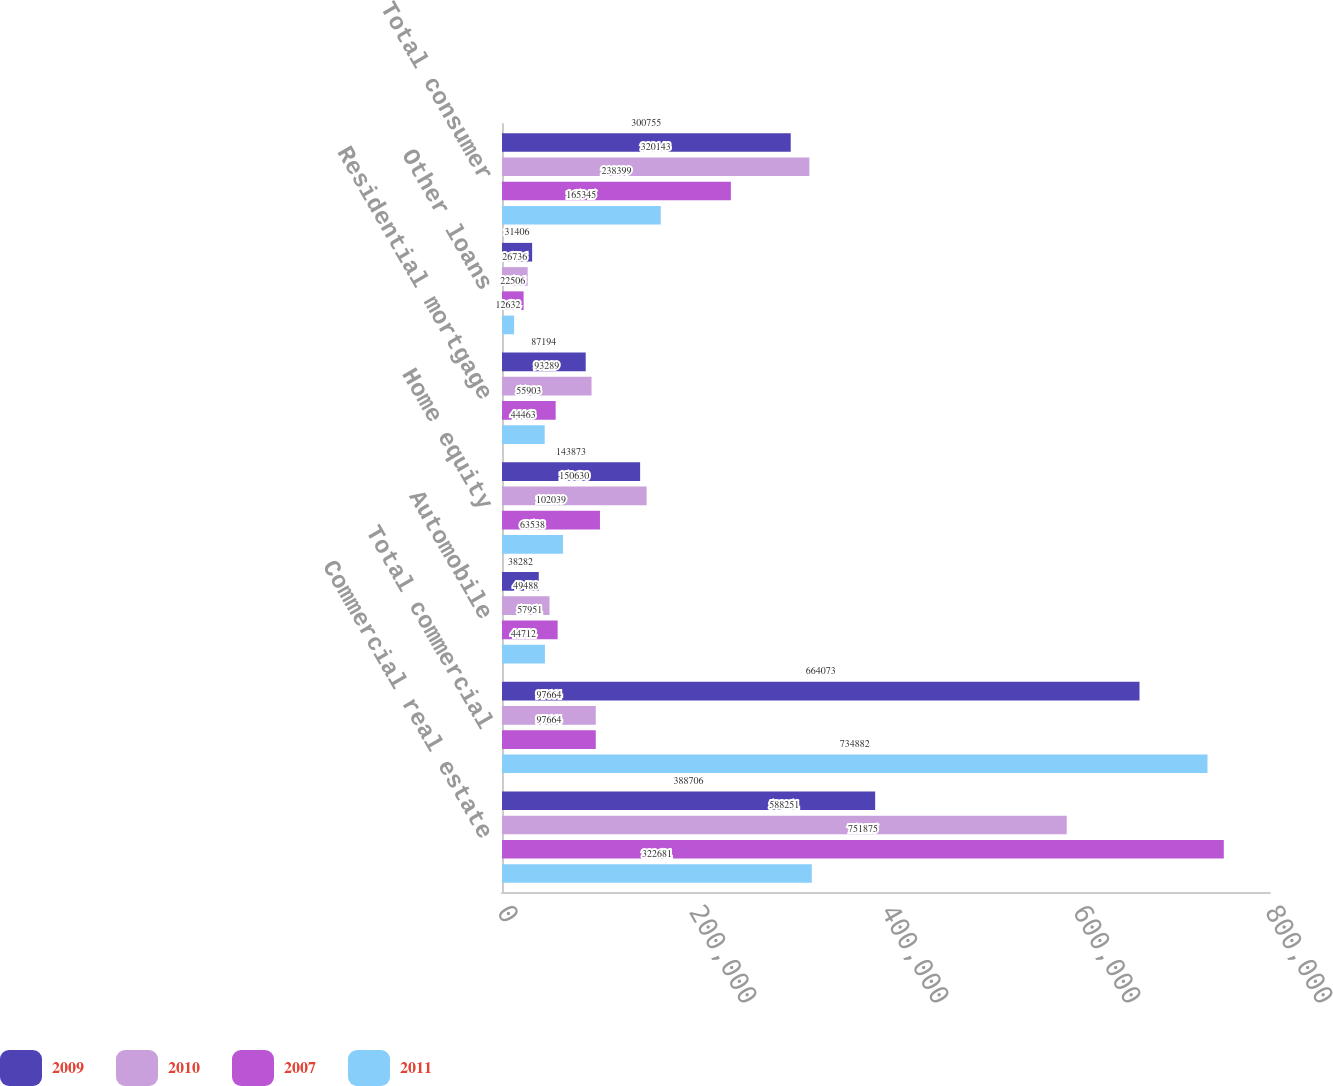Convert chart to OTSL. <chart><loc_0><loc_0><loc_500><loc_500><stacked_bar_chart><ecel><fcel>Commercial real estate<fcel>Total commercial<fcel>Automobile<fcel>Home equity<fcel>Residential mortgage<fcel>Other loans<fcel>Total consumer<nl><fcel>2009<fcel>388706<fcel>664073<fcel>38282<fcel>143873<fcel>87194<fcel>31406<fcel>300755<nl><fcel>2010<fcel>588251<fcel>97664<fcel>49488<fcel>150630<fcel>93289<fcel>26736<fcel>320143<nl><fcel>2007<fcel>751875<fcel>97664<fcel>57951<fcel>102039<fcel>55903<fcel>22506<fcel>238399<nl><fcel>2011<fcel>322681<fcel>734882<fcel>44712<fcel>63538<fcel>44463<fcel>12632<fcel>165345<nl></chart> 